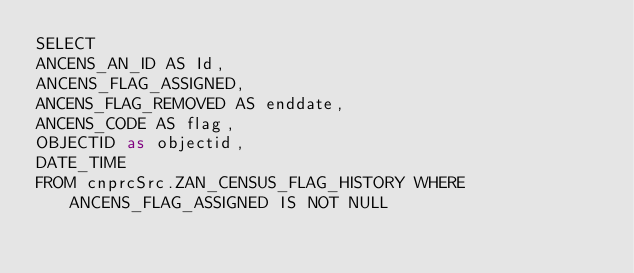<code> <loc_0><loc_0><loc_500><loc_500><_SQL_>SELECT
ANCENS_AN_ID AS Id,
ANCENS_FLAG_ASSIGNED,
ANCENS_FLAG_REMOVED AS enddate,
ANCENS_CODE AS flag,
OBJECTID as objectid,
DATE_TIME
FROM cnprcSrc.ZAN_CENSUS_FLAG_HISTORY WHERE ANCENS_FLAG_ASSIGNED IS NOT NULL</code> 